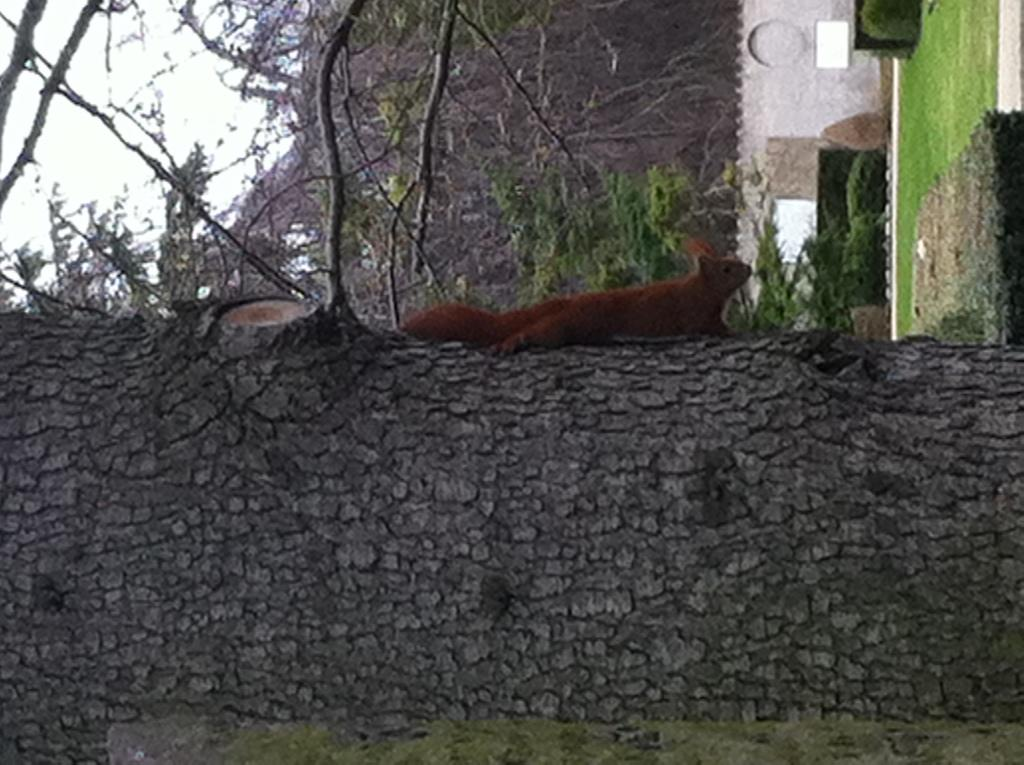What animal is present in the image? There is a squirrel in the image. Where is the squirrel located? The squirrel is on a tree. What can be seen in the background of the image? There is a group of trees, plants, and the sky visible in the background of the image. What type of haircut does the squirrel have in the image? The squirrel does not have a haircut in the image, as it is a wild animal with natural fur. 